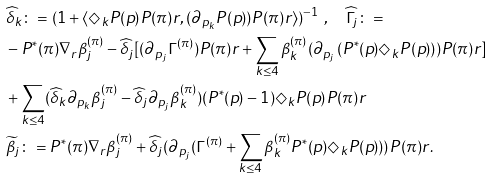Convert formula to latex. <formula><loc_0><loc_0><loc_500><loc_500>& \widehat { \delta } _ { k } \colon = ( 1 + \langle \Diamond _ { k } P ( p ) P ( \pi ) r , ( \partial _ { p _ { k } } P ( p ) ) P ( \pi ) r \rangle ) ^ { - 1 } \ , \quad \widehat { \Gamma } _ { j } \colon = \\ & - P ^ { * } ( \pi ) \nabla _ { r } \beta _ { j } ^ { ( \pi ) } - \widehat { \delta } _ { j } [ ( \partial _ { p _ { j } } \Gamma ^ { ( \pi ) } ) P ( \pi ) r + \sum _ { k \leq 4 } \beta ^ { ( \pi ) } _ { k } ( \partial _ { p _ { j } } \left ( P ^ { * } ( p ) \Diamond _ { k } P ( p ) \right ) ) P ( \pi ) r ] \\ & + \sum _ { k \leq 4 } ( \widehat { \delta } _ { k } \partial _ { p _ { k } } { \beta } _ { j } ^ { ( \pi ) } - \widehat { \delta } _ { j } \partial _ { p _ { j } } { \beta } _ { k } ^ { ( \pi ) } ) ( P ^ { * } ( p ) - 1 ) \Diamond _ { k } P ( p ) P ( \pi ) r \\ & \widetilde { \beta } _ { j } \colon = P ^ { * } ( \pi ) \nabla _ { r } \beta _ { j } ^ { ( \pi ) } + \widehat { \delta } _ { j } ( \partial _ { p _ { j } } ( \Gamma ^ { ( \pi ) } + \sum _ { k \leq 4 } \beta _ { k } ^ { ( \pi ) } P ^ { * } ( p ) \Diamond _ { k } P ( p ) ) ) P ( \pi ) r .</formula> 